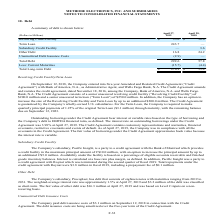According to Methode Electronics's financial document, What was the weighted-average interest rate in 2019? According to the financial document, 1.5%. The relevant text states: "e weighted-average interest rate was approximately 1.5% at April 27, 2019 and $3.2 million of the debt was classified as short-term. The fair value of other..." Also, What was the debt issuance cost in 2018? According to the financial document, $3.1 million. The relevant text states: "ipal payments of 1.25% of the original Term Loan ($3.1 million) through maturity, with the remaining balance due on September 12, 2023. Outstanding borrowings und..." Also, What was the Revolving Credit Facility in 2019 and 2018 respectively? The document shows two values: 35.0 and 30.0 (in millions). From the document: "Revolving Credit Facility $ 35.0 $ 30.0 Revolving Credit Facility $ 35.0 $ 30.0..." Also, can you calculate: What was the change in the Revolving Credit Facility from 2018 to 2019? Based on the calculation: 35.0 - 30.0, the result is 5 (in millions). This is based on the information: "Revolving Credit Facility $ 35.0 $ 30.0 Revolving Credit Facility $ 35.0 $ 30.0..." The key data points involved are: 30.0, 35.0. Also, can you calculate: What was the average Term loan for 2018 and 2019? To answer this question, I need to perform calculations using the financial data. The calculation is: (243.7 + 0) / 2, which equals 121.85 (in millions). This is based on the information: "Term Loan 243.7 — Term Loan 243.7 —..." The key data points involved are: 0, 243.7. Additionally, In which year was Other Debt less than 20.0 million? According to the financial document, 2019. The relevant text states: "2019..." 